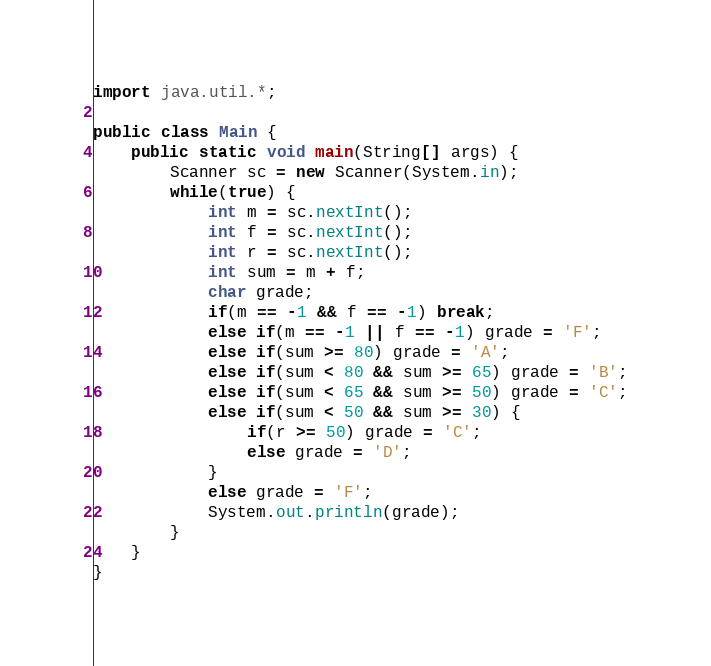<code> <loc_0><loc_0><loc_500><loc_500><_Java_>import java.util.*;

public class Main {
    public static void main(String[] args) {
        Scanner sc = new Scanner(System.in);
        while(true) {
            int m = sc.nextInt();
            int f = sc.nextInt();
            int r = sc.nextInt();
            int sum = m + f;
            char grade; 
            if(m == -1 && f == -1) break;
            else if(m == -1 || f == -1) grade = 'F';
            else if(sum >= 80) grade = 'A';
            else if(sum < 80 && sum >= 65) grade = 'B';
            else if(sum < 65 && sum >= 50) grade = 'C';
            else if(sum < 50 && sum >= 30) {
                if(r >= 50) grade = 'C';
                else grade = 'D';
            }
            else grade = 'F';
            System.out.println(grade);
        }
    }
}
</code> 